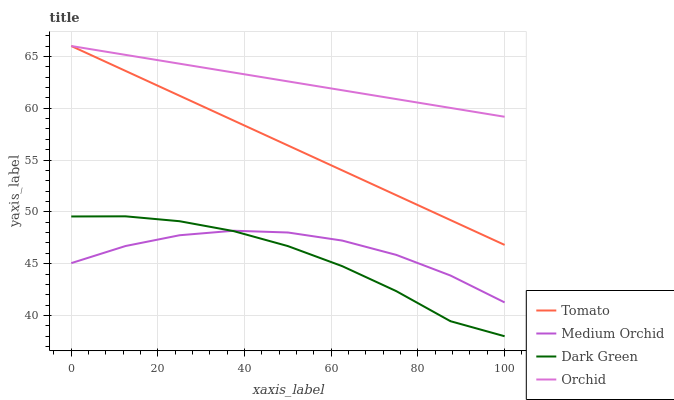Does Medium Orchid have the minimum area under the curve?
Answer yes or no. No. Does Medium Orchid have the maximum area under the curve?
Answer yes or no. No. Is Medium Orchid the smoothest?
Answer yes or no. No. Is Medium Orchid the roughest?
Answer yes or no. No. Does Medium Orchid have the lowest value?
Answer yes or no. No. Does Medium Orchid have the highest value?
Answer yes or no. No. Is Medium Orchid less than Orchid?
Answer yes or no. Yes. Is Tomato greater than Dark Green?
Answer yes or no. Yes. Does Medium Orchid intersect Orchid?
Answer yes or no. No. 